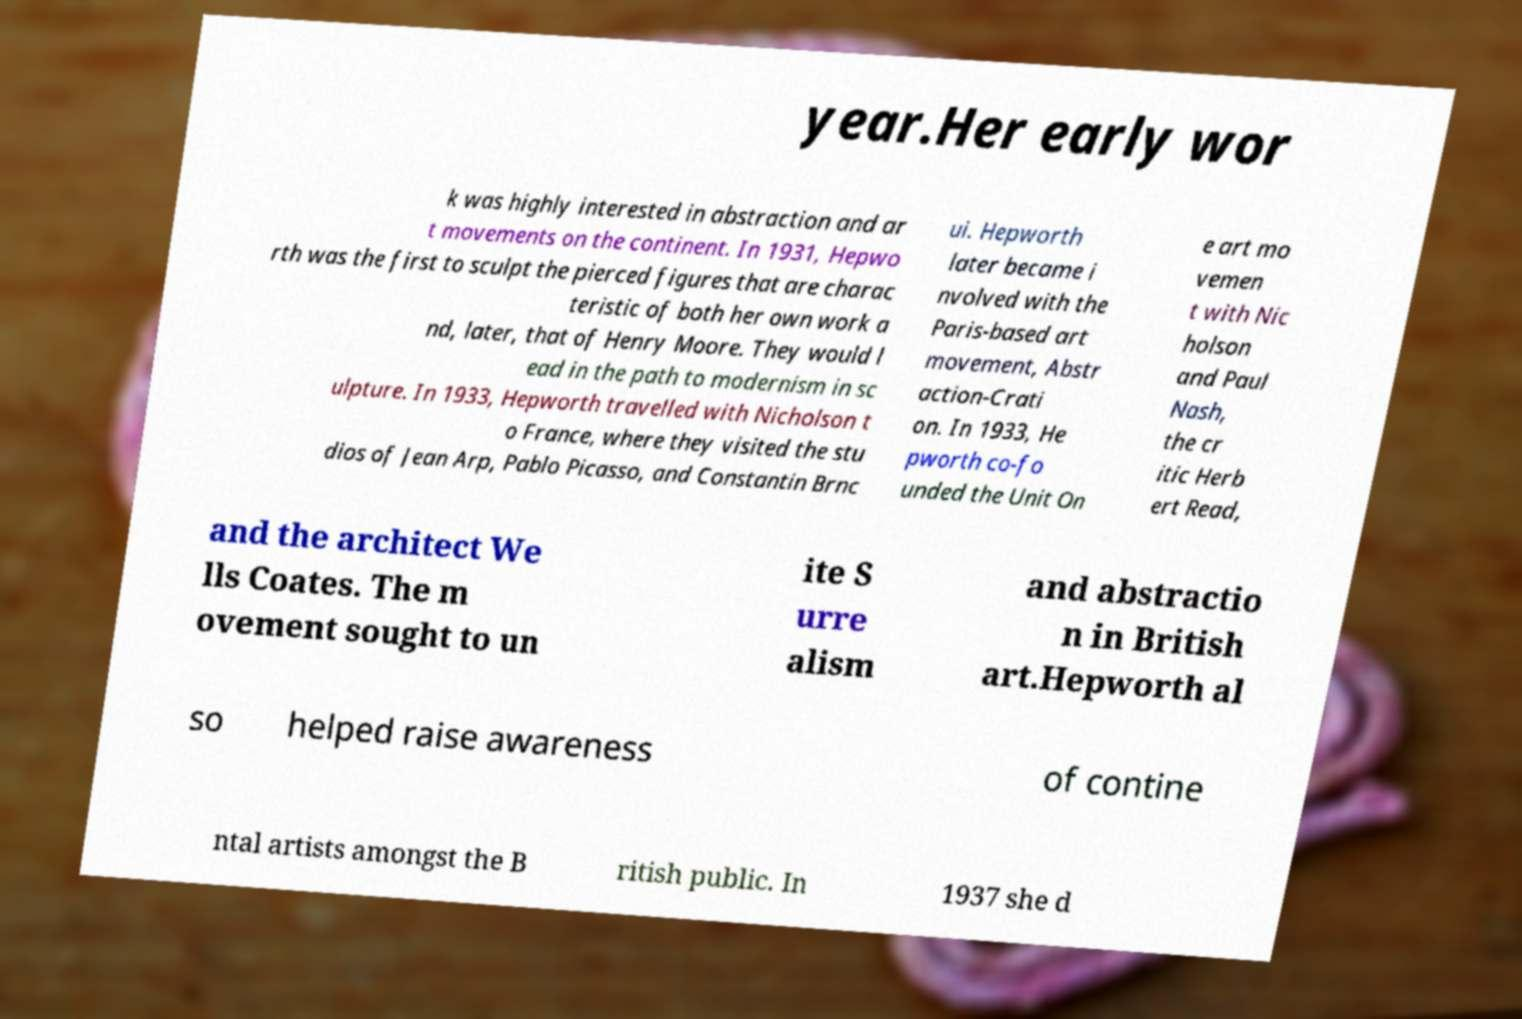There's text embedded in this image that I need extracted. Can you transcribe it verbatim? year.Her early wor k was highly interested in abstraction and ar t movements on the continent. In 1931, Hepwo rth was the first to sculpt the pierced figures that are charac teristic of both her own work a nd, later, that of Henry Moore. They would l ead in the path to modernism in sc ulpture. In 1933, Hepworth travelled with Nicholson t o France, where they visited the stu dios of Jean Arp, Pablo Picasso, and Constantin Brnc ui. Hepworth later became i nvolved with the Paris-based art movement, Abstr action-Crati on. In 1933, He pworth co-fo unded the Unit On e art mo vemen t with Nic holson and Paul Nash, the cr itic Herb ert Read, and the architect We lls Coates. The m ovement sought to un ite S urre alism and abstractio n in British art.Hepworth al so helped raise awareness of contine ntal artists amongst the B ritish public. In 1937 she d 